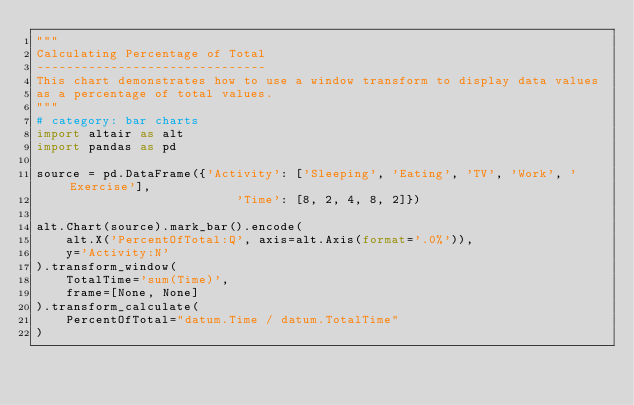<code> <loc_0><loc_0><loc_500><loc_500><_Python_>"""
Calculating Percentage of Total
-------------------------------
This chart demonstrates how to use a window transform to display data values
as a percentage of total values.
"""
# category: bar charts
import altair as alt
import pandas as pd

source = pd.DataFrame({'Activity': ['Sleeping', 'Eating', 'TV', 'Work', 'Exercise'],
                           'Time': [8, 2, 4, 8, 2]})

alt.Chart(source).mark_bar().encode(
    alt.X('PercentOfTotal:Q', axis=alt.Axis(format='.0%')),
    y='Activity:N'
).transform_window(
    TotalTime='sum(Time)',
    frame=[None, None]
).transform_calculate(
    PercentOfTotal="datum.Time / datum.TotalTime"
)
</code> 